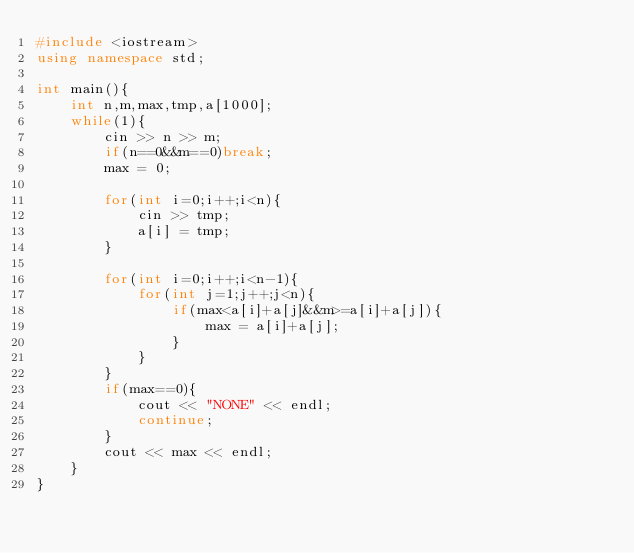<code> <loc_0><loc_0><loc_500><loc_500><_C++_>#include <iostream>
using namespace std;

int main(){
	int n,m,max,tmp,a[1000];
	while(1){
		cin >> n >> m;
		if(n==0&&m==0)break;
		max = 0;

		for(int i=0;i++;i<n){
			cin >> tmp;
			a[i] = tmp;
		}

		for(int i=0;i++;i<n-1){
			for(int j=1;j++;j<n){
				if(max<a[i]+a[j]&&m>=a[i]+a[j]){
					max = a[i]+a[j];
				}
			}
		}
		if(max==0){
			cout << "NONE" << endl;
			continue;
		}
		cout << max << endl;
	}
}</code> 